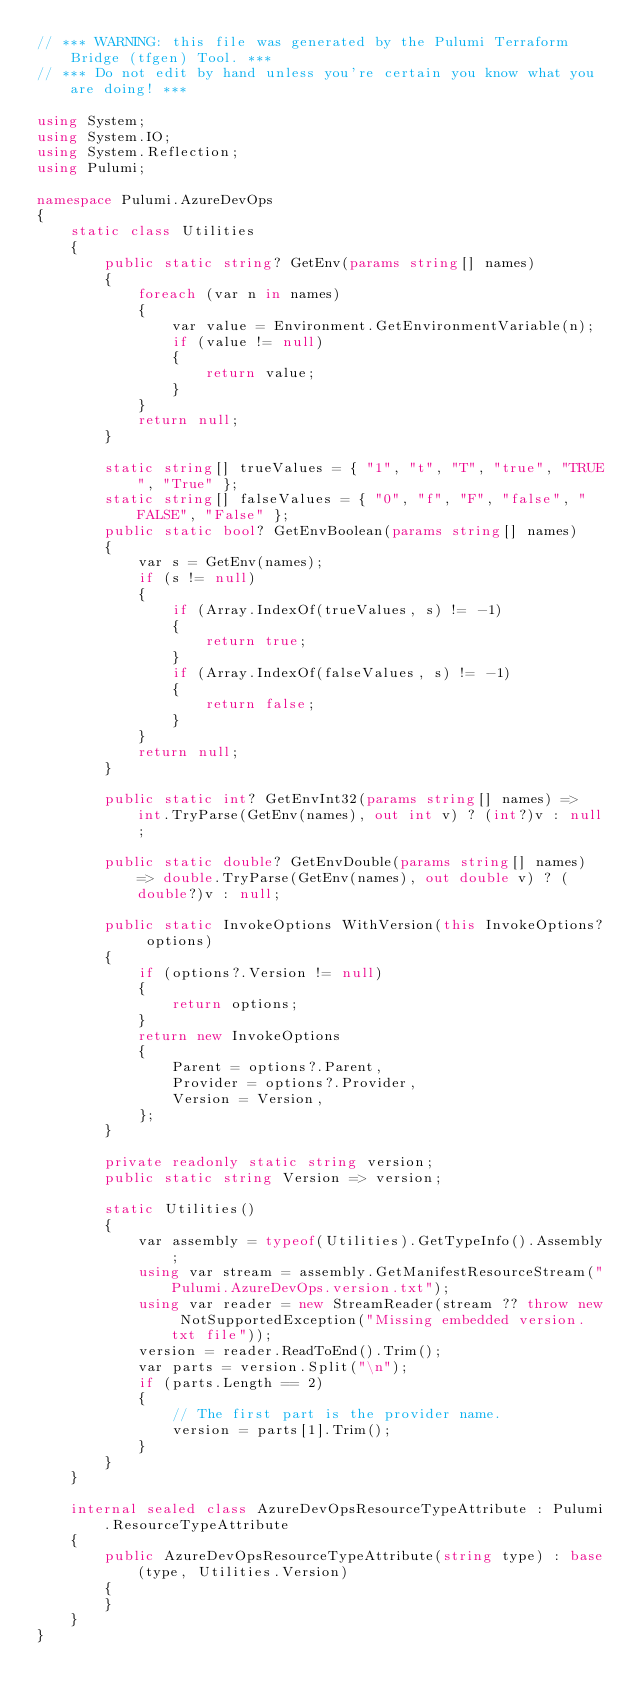Convert code to text. <code><loc_0><loc_0><loc_500><loc_500><_C#_>// *** WARNING: this file was generated by the Pulumi Terraform Bridge (tfgen) Tool. ***
// *** Do not edit by hand unless you're certain you know what you are doing! ***

using System;
using System.IO;
using System.Reflection;
using Pulumi;

namespace Pulumi.AzureDevOps
{
    static class Utilities
    {
        public static string? GetEnv(params string[] names)
        {
            foreach (var n in names)
            {
                var value = Environment.GetEnvironmentVariable(n);
                if (value != null)
                {
                    return value;
                }
            }
            return null;
        }

        static string[] trueValues = { "1", "t", "T", "true", "TRUE", "True" };
        static string[] falseValues = { "0", "f", "F", "false", "FALSE", "False" };
        public static bool? GetEnvBoolean(params string[] names)
        {
            var s = GetEnv(names);
            if (s != null)
            {
                if (Array.IndexOf(trueValues, s) != -1)
                {
                    return true;
                }
                if (Array.IndexOf(falseValues, s) != -1)
                {
                    return false;
                }
            }
            return null;
        }

        public static int? GetEnvInt32(params string[] names) => int.TryParse(GetEnv(names), out int v) ? (int?)v : null;

        public static double? GetEnvDouble(params string[] names) => double.TryParse(GetEnv(names), out double v) ? (double?)v : null;

        public static InvokeOptions WithVersion(this InvokeOptions? options)
        {
            if (options?.Version != null)
            {
                return options;
            }
            return new InvokeOptions
            {
                Parent = options?.Parent,
                Provider = options?.Provider,
                Version = Version,
            };
        }

        private readonly static string version;
        public static string Version => version;

        static Utilities()
        {
            var assembly = typeof(Utilities).GetTypeInfo().Assembly;
            using var stream = assembly.GetManifestResourceStream("Pulumi.AzureDevOps.version.txt");
            using var reader = new StreamReader(stream ?? throw new NotSupportedException("Missing embedded version.txt file"));
            version = reader.ReadToEnd().Trim();
            var parts = version.Split("\n");
            if (parts.Length == 2)
            {
                // The first part is the provider name.
                version = parts[1].Trim();
            }
        }
    }

    internal sealed class AzureDevOpsResourceTypeAttribute : Pulumi.ResourceTypeAttribute
    {
        public AzureDevOpsResourceTypeAttribute(string type) : base(type, Utilities.Version)
        {
        }
    }
}
</code> 